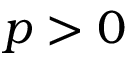Convert formula to latex. <formula><loc_0><loc_0><loc_500><loc_500>p > 0</formula> 